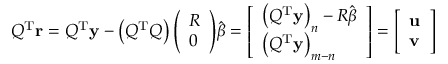Convert formula to latex. <formula><loc_0><loc_0><loc_500><loc_500>Q ^ { T } r = Q ^ { T } y - \left ( Q ^ { T } Q \right ) { \left ( \begin{array} { l } { R } \\ { 0 } \end{array} \right ) } { \hat { \beta } } = { \left [ \begin{array} { l } { \left ( Q ^ { T } y \right ) _ { n } - R { \hat { \beta } } } \\ { \left ( Q ^ { T } y \right ) _ { m - n } } \end{array} \right ] } = { \left [ \begin{array} { l } { u } \\ { v } \end{array} \right ] }</formula> 